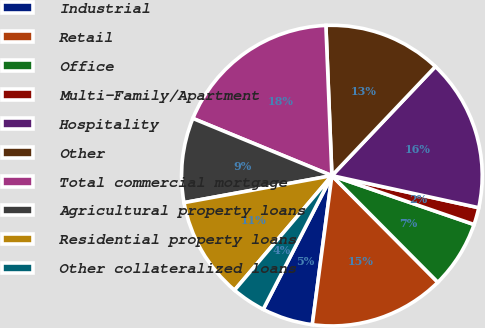<chart> <loc_0><loc_0><loc_500><loc_500><pie_chart><fcel>Industrial<fcel>Retail<fcel>Office<fcel>Multi-Family/Apartment<fcel>Hospitality<fcel>Other<fcel>Total commercial mortgage<fcel>Agricultural property loans<fcel>Residential property loans<fcel>Other collateralized loans<nl><fcel>5.47%<fcel>14.53%<fcel>7.28%<fcel>1.85%<fcel>16.34%<fcel>12.72%<fcel>18.15%<fcel>9.09%<fcel>10.91%<fcel>3.66%<nl></chart> 